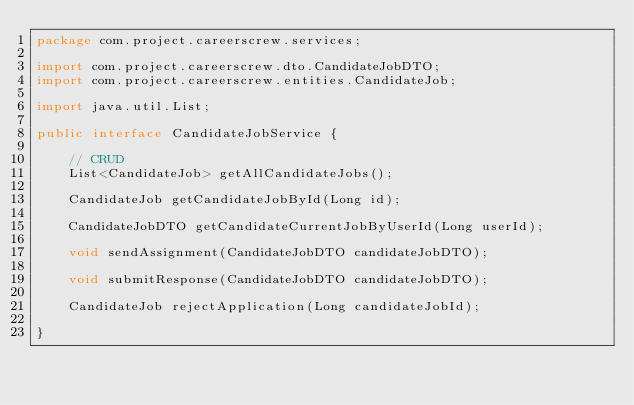Convert code to text. <code><loc_0><loc_0><loc_500><loc_500><_Java_>package com.project.careerscrew.services;

import com.project.careerscrew.dto.CandidateJobDTO;
import com.project.careerscrew.entities.CandidateJob;

import java.util.List;

public interface CandidateJobService {

    // CRUD
    List<CandidateJob> getAllCandidateJobs();

    CandidateJob getCandidateJobById(Long id);

    CandidateJobDTO getCandidateCurrentJobByUserId(Long userId);

    void sendAssignment(CandidateJobDTO candidateJobDTO);

    void submitResponse(CandidateJobDTO candidateJobDTO);

    CandidateJob rejectApplication(Long candidateJobId);

}
</code> 